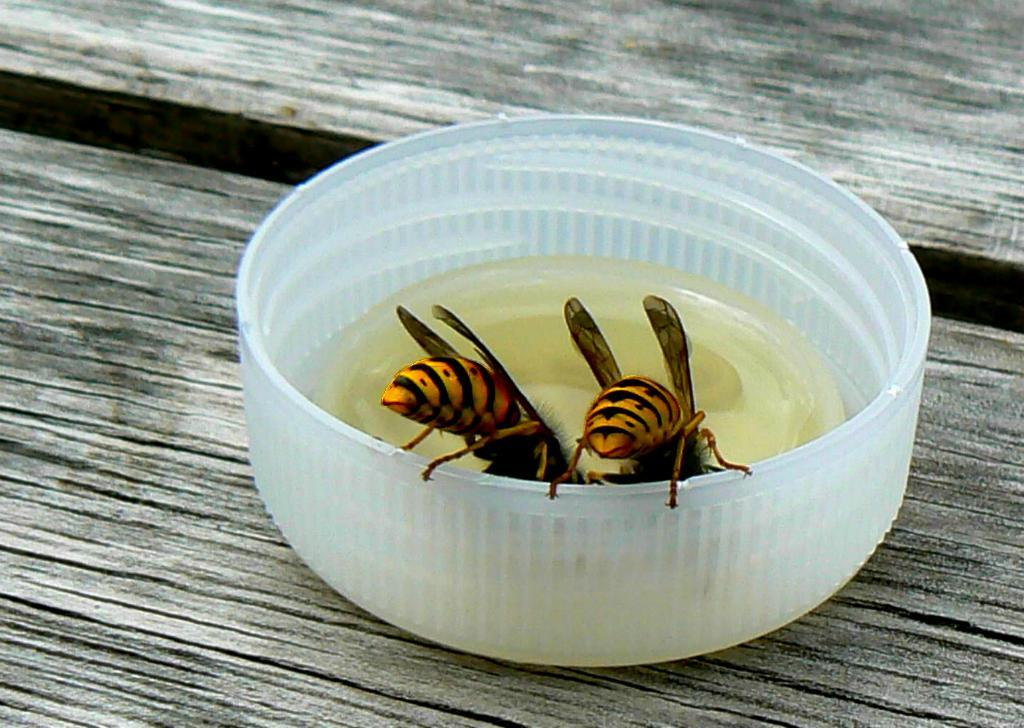What is on the plastic container in the image? There are two insects on the plastic container. What is inside the container? There is a liquid inside the container. Where is the container placed? The container is placed on a wooden surface. What type of creature can be seen at the airport in the image? There is no airport or creature present in the image; it features two insects on a plastic container with a liquid inside, placed on a wooden surface. 